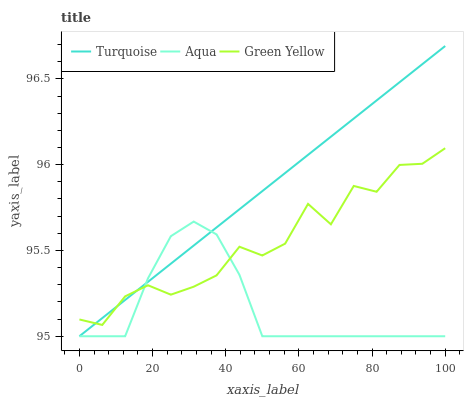Does Aqua have the minimum area under the curve?
Answer yes or no. Yes. Does Turquoise have the maximum area under the curve?
Answer yes or no. Yes. Does Green Yellow have the minimum area under the curve?
Answer yes or no. No. Does Green Yellow have the maximum area under the curve?
Answer yes or no. No. Is Turquoise the smoothest?
Answer yes or no. Yes. Is Green Yellow the roughest?
Answer yes or no. Yes. Is Aqua the smoothest?
Answer yes or no. No. Is Aqua the roughest?
Answer yes or no. No. Does Turquoise have the lowest value?
Answer yes or no. Yes. Does Green Yellow have the lowest value?
Answer yes or no. No. Does Turquoise have the highest value?
Answer yes or no. Yes. Does Green Yellow have the highest value?
Answer yes or no. No. Does Green Yellow intersect Aqua?
Answer yes or no. Yes. Is Green Yellow less than Aqua?
Answer yes or no. No. Is Green Yellow greater than Aqua?
Answer yes or no. No. 